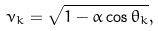Convert formula to latex. <formula><loc_0><loc_0><loc_500><loc_500>\nu _ { k } = \sqrt { 1 - \alpha \cos \theta _ { k } } ,</formula> 